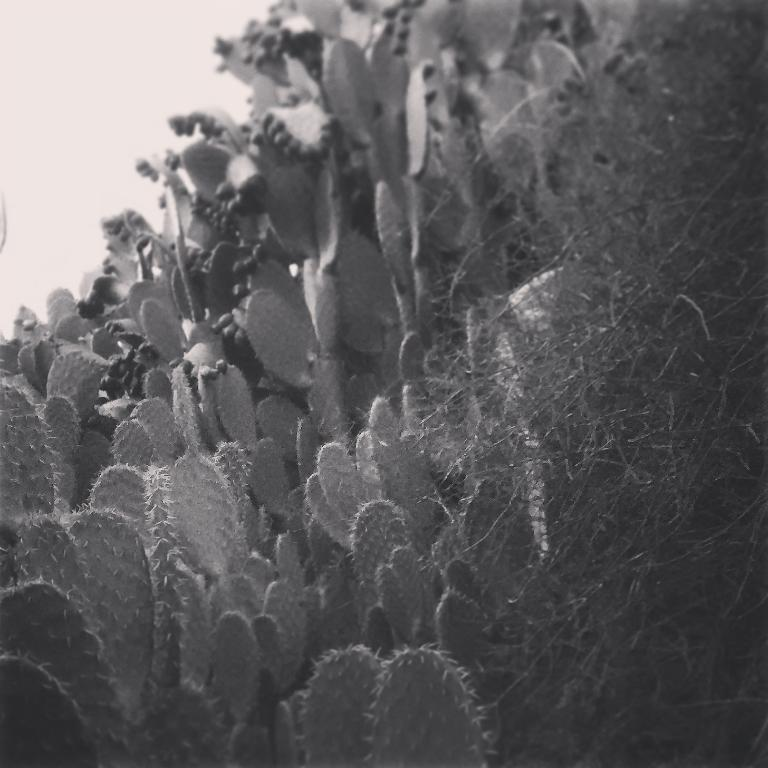What celestial objects are depicted in the image? There are planets in the image. What is the color scheme of the image? The image is black and white in color. How is the background of the image? The background of the image is slightly blurry. What type of error can be seen in the image? There is no error present in the image; it is a depiction of planets. Can you spot any bees in the image? There are no bees present in the image; it features planets. 